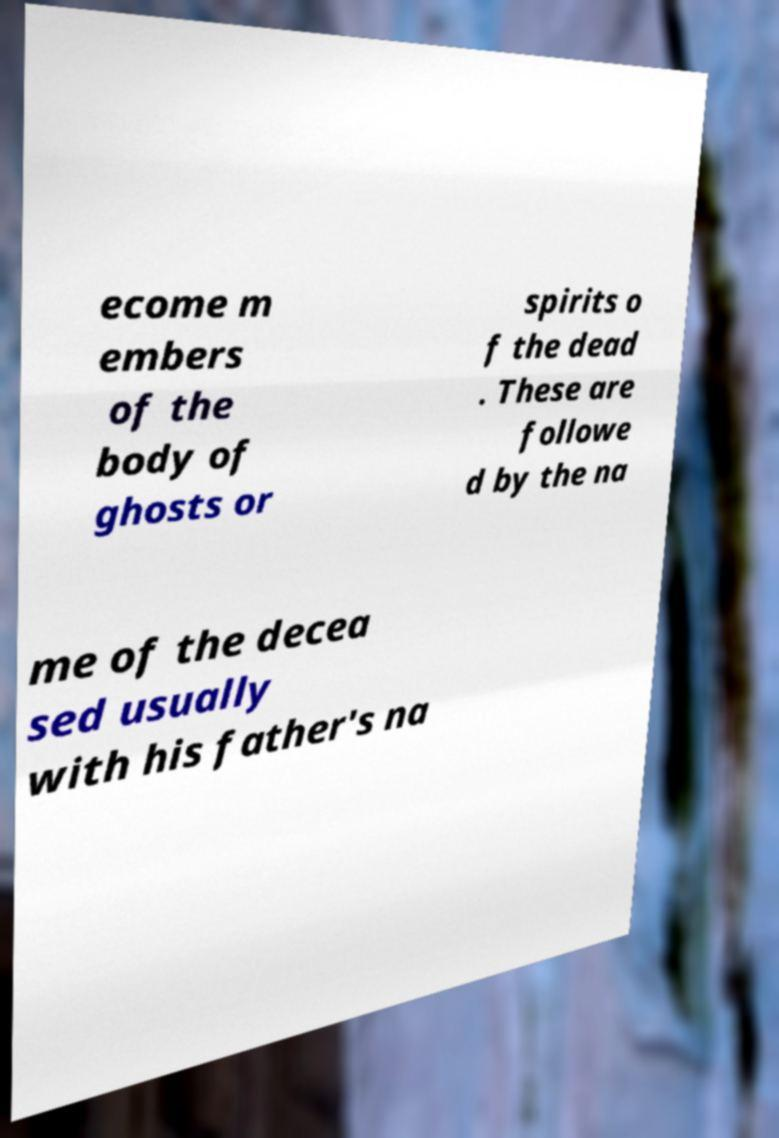Can you accurately transcribe the text from the provided image for me? ecome m embers of the body of ghosts or spirits o f the dead . These are followe d by the na me of the decea sed usually with his father's na 